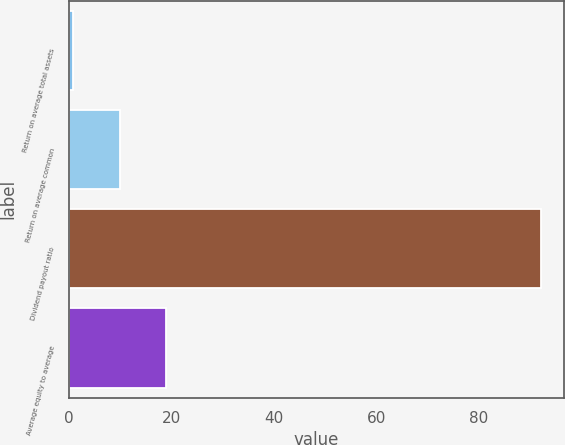<chart> <loc_0><loc_0><loc_500><loc_500><bar_chart><fcel>Return on average total assets<fcel>Return on average common<fcel>Dividend payout ratio<fcel>Average equity to average<nl><fcel>0.68<fcel>9.82<fcel>92.05<fcel>18.96<nl></chart> 